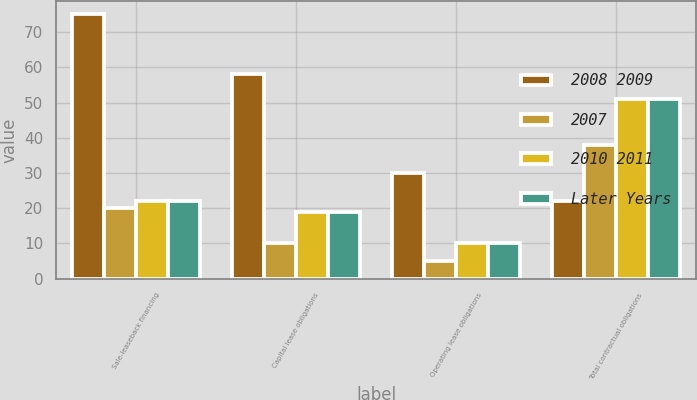<chart> <loc_0><loc_0><loc_500><loc_500><stacked_bar_chart><ecel><fcel>Sale-leaseback financing<fcel>Capital lease obligations<fcel>Operating lease obligations<fcel>Total contractual obligations<nl><fcel>2008 2009<fcel>75<fcel>58<fcel>30<fcel>22<nl><fcel>2007<fcel>20<fcel>10<fcel>5<fcel>38<nl><fcel>2010 2011<fcel>22<fcel>19<fcel>10<fcel>51<nl><fcel>Later Years<fcel>22<fcel>19<fcel>10<fcel>51<nl></chart> 